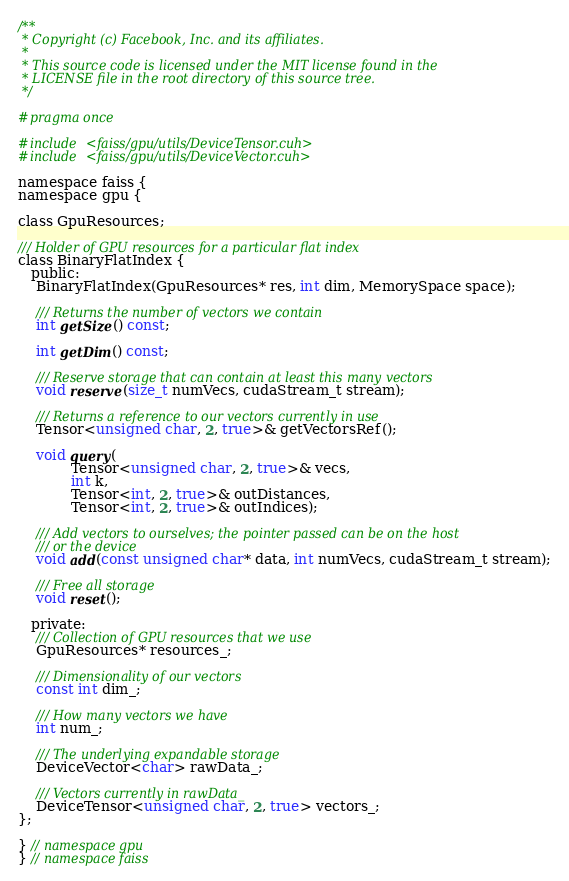<code> <loc_0><loc_0><loc_500><loc_500><_Cuda_>/**
 * Copyright (c) Facebook, Inc. and its affiliates.
 *
 * This source code is licensed under the MIT license found in the
 * LICENSE file in the root directory of this source tree.
 */

#pragma once

#include <faiss/gpu/utils/DeviceTensor.cuh>
#include <faiss/gpu/utils/DeviceVector.cuh>

namespace faiss {
namespace gpu {

class GpuResources;

/// Holder of GPU resources for a particular flat index
class BinaryFlatIndex {
   public:
    BinaryFlatIndex(GpuResources* res, int dim, MemorySpace space);

    /// Returns the number of vectors we contain
    int getSize() const;

    int getDim() const;

    /// Reserve storage that can contain at least this many vectors
    void reserve(size_t numVecs, cudaStream_t stream);

    /// Returns a reference to our vectors currently in use
    Tensor<unsigned char, 2, true>& getVectorsRef();

    void query(
            Tensor<unsigned char, 2, true>& vecs,
            int k,
            Tensor<int, 2, true>& outDistances,
            Tensor<int, 2, true>& outIndices);

    /// Add vectors to ourselves; the pointer passed can be on the host
    /// or the device
    void add(const unsigned char* data, int numVecs, cudaStream_t stream);

    /// Free all storage
    void reset();

   private:
    /// Collection of GPU resources that we use
    GpuResources* resources_;

    /// Dimensionality of our vectors
    const int dim_;

    /// How many vectors we have
    int num_;

    /// The underlying expandable storage
    DeviceVector<char> rawData_;

    /// Vectors currently in rawData_
    DeviceTensor<unsigned char, 2, true> vectors_;
};

} // namespace gpu
} // namespace faiss
</code> 